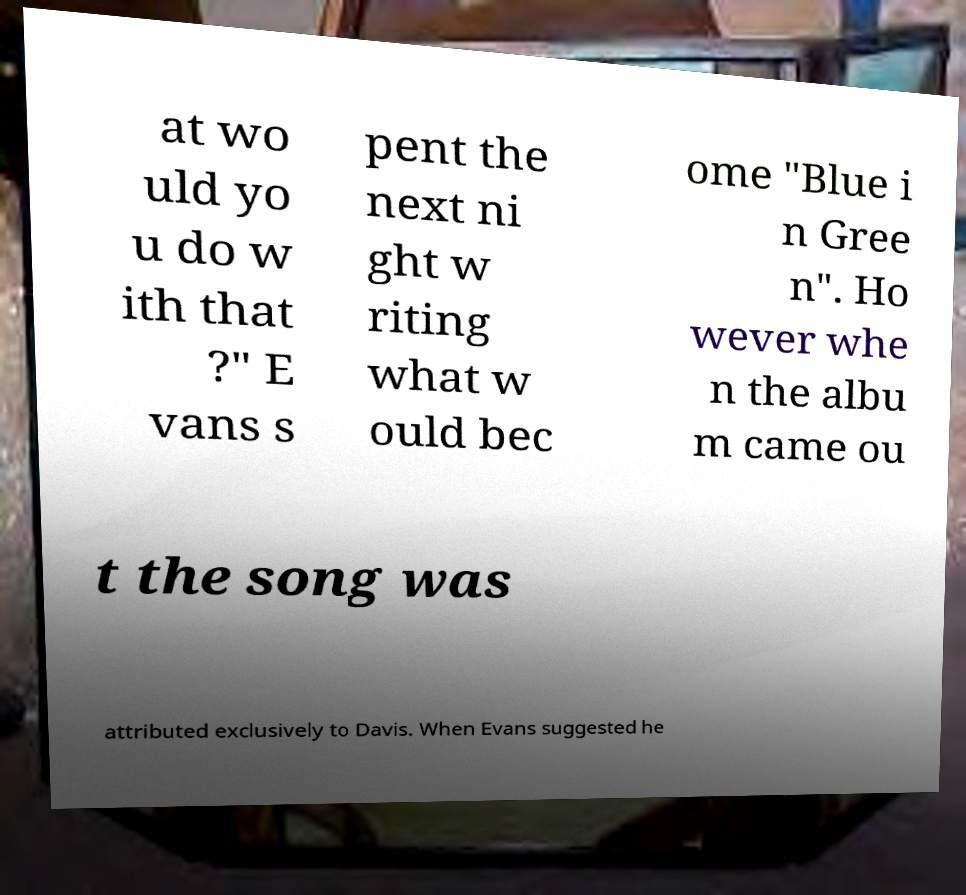Please read and relay the text visible in this image. What does it say? at wo uld yo u do w ith that ?" E vans s pent the next ni ght w riting what w ould bec ome "Blue i n Gree n". Ho wever whe n the albu m came ou t the song was attributed exclusively to Davis. When Evans suggested he 